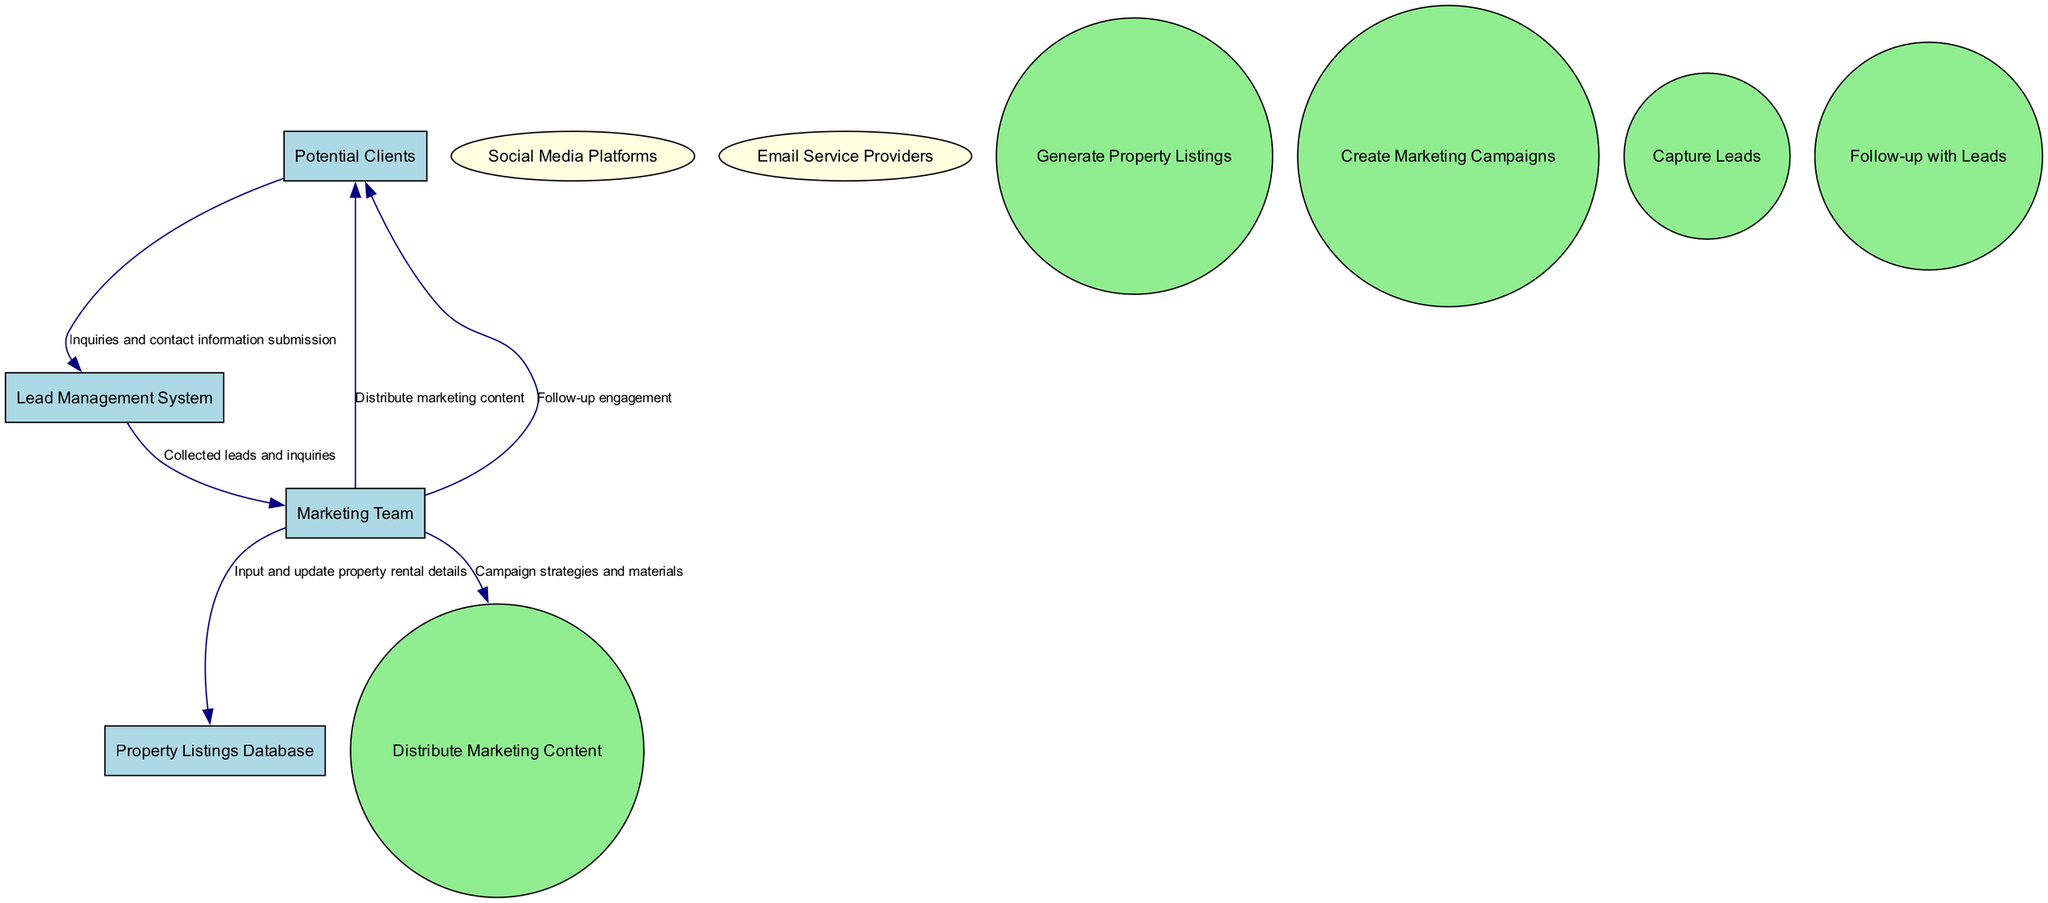What is the name of the entity that represents individuals searching for vacation rentals? According to the diagram, the entity that represents individuals searching for vacation rentals is labeled "Potential Clients." This is found in the list of entities at the beginning of the diagram.
Answer: Potential Clients How many processes are depicted in the diagram? The diagram shows five processes that include generating property listings, creating marketing campaigns, distributing marketing content, capturing leads, and following up with leads. By counting these processes, we find a total of five.
Answer: 5 What type of system tracks potential client interactions and follow-ups? The system that tracks potential client interactions and follow-ups is described in the diagram as the "Lead Management System." This can be found in the list of entities as well.
Answer: Lead Management System Which entity distributes marketing content to potential clients? The "Marketing Team" is responsible for distributing marketing content to potential clients as indicated by the flow from the Marketing Team to Potential Clients in the data flows section of the diagram.
Answer: Marketing Team What type of communication does the "Lead Management System" provide to the "Marketing Team"? The "Lead Management System" provides collected leads and inquiries to the "Marketing Team." This connection is specifically mentioned in the data flow detailing the exchange of information between these two entities.
Answer: Collected leads and inquiries How does the "Marketing Team" engage with potential clients? The "Marketing Team" engages with potential clients through follow-up communications, as indicated in the data flow from the Marketing Team to Potential Clients labeled "Follow-up engagement." This represents the Marketing Team's interaction with potential clients after initial leads are captured.
Answer: Follow-up engagement Which external entity is responsible for channels of distributing promotional content? The entity responsible for channels of distributing promotional content is the "Social Media Platforms." This is classified as an external entity in the diagram, indicating its role in content distribution.
Answer: Social Media Platforms What does the data flow from "Potential Clients" to the "Lead Management System" consist of? The data flow from "Potential Clients" to the "Lead Management System" consists of inquiries and contact information submission. This flow is explicitly described in the data flow section of the diagram, detailing what information is transferred.
Answer: Inquiries and contact information submission What shape represents the processes in the diagram? The processes in the diagram are represented by circles. This is a specific design element used to differentiate processes from entities and external entities, which are represented in different shapes.
Answer: Circle 